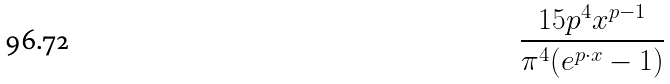Convert formula to latex. <formula><loc_0><loc_0><loc_500><loc_500>\frac { 1 5 p ^ { 4 } x ^ { p - 1 } } { \pi ^ { 4 } ( e ^ { p \cdot x } - 1 ) }</formula> 